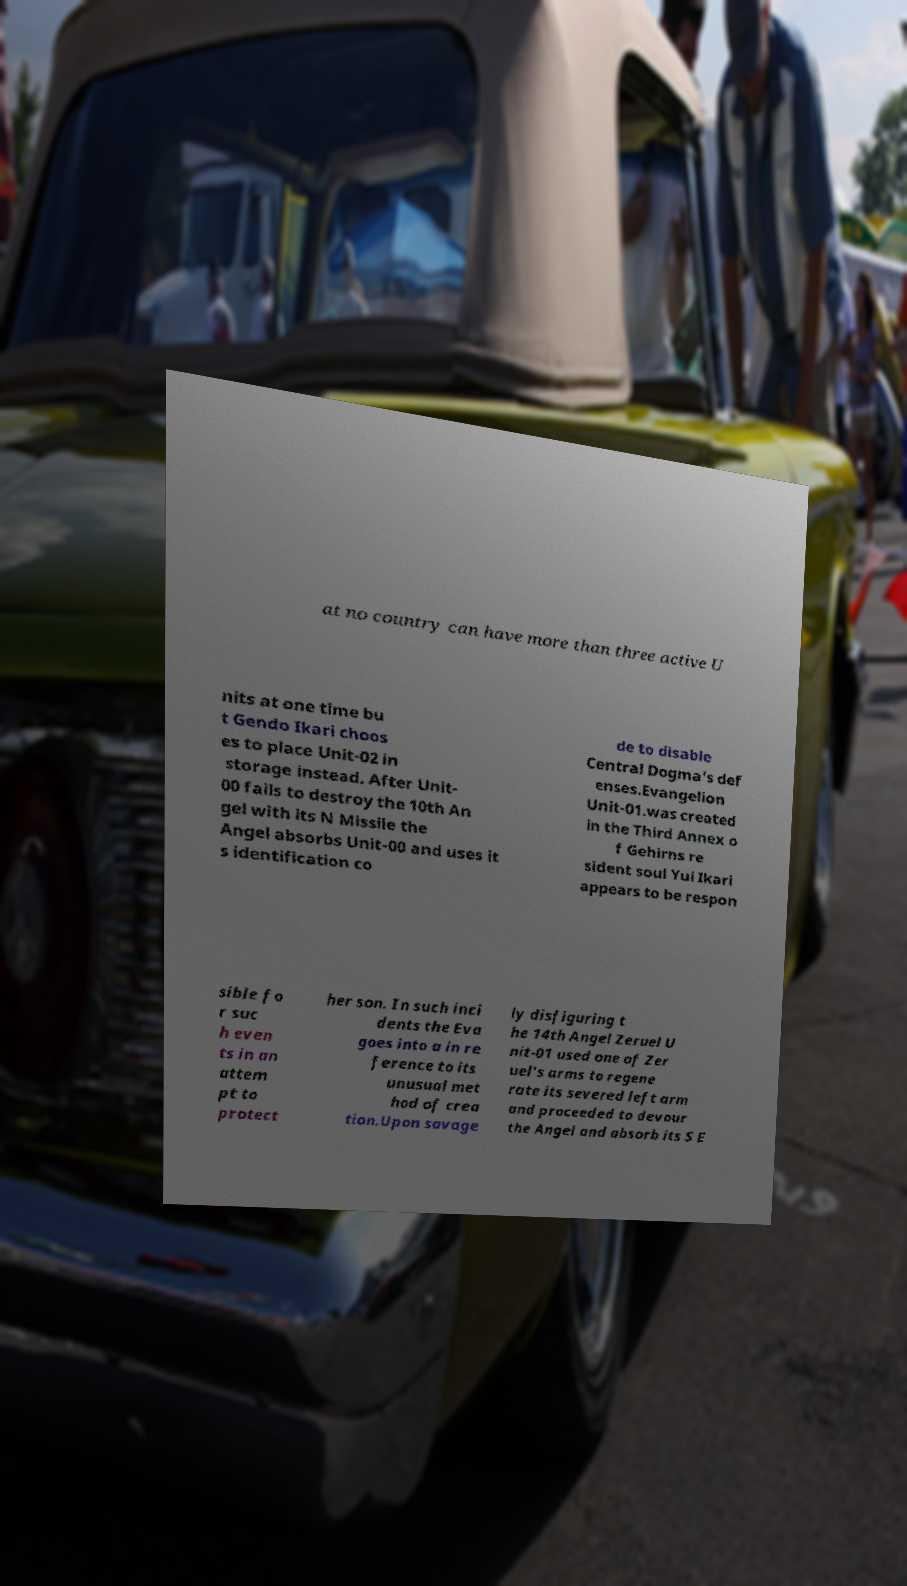Please read and relay the text visible in this image. What does it say? at no country can have more than three active U nits at one time bu t Gendo Ikari choos es to place Unit-02 in storage instead. After Unit- 00 fails to destroy the 10th An gel with its N Missile the Angel absorbs Unit-00 and uses it s identification co de to disable Central Dogma's def enses.Evangelion Unit-01.was created in the Third Annex o f Gehirns re sident soul Yui Ikari appears to be respon sible fo r suc h even ts in an attem pt to protect her son. In such inci dents the Eva goes into a in re ference to its unusual met hod of crea tion.Upon savage ly disfiguring t he 14th Angel Zeruel U nit-01 used one of Zer uel's arms to regene rate its severed left arm and proceeded to devour the Angel and absorb its S E 